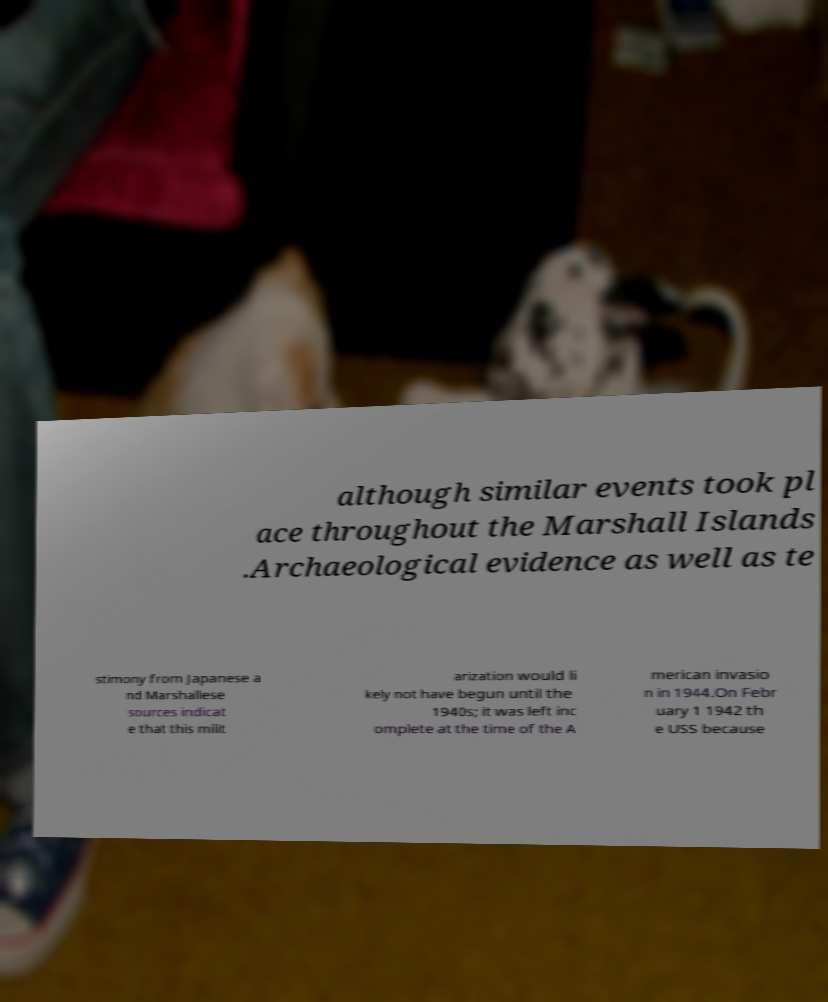Can you accurately transcribe the text from the provided image for me? although similar events took pl ace throughout the Marshall Islands .Archaeological evidence as well as te stimony from Japanese a nd Marshallese sources indicat e that this milit arization would li kely not have begun until the 1940s; it was left inc omplete at the time of the A merican invasio n in 1944.On Febr uary 1 1942 th e USS because 